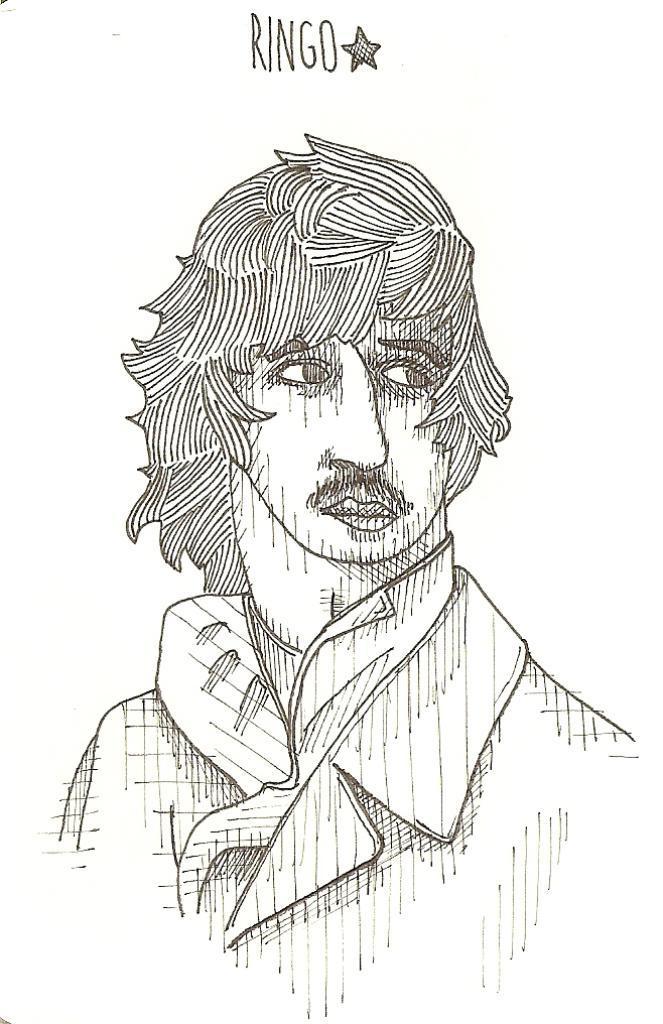Describe this image in one or two sentences. In this image I can see a sketch drawing of a person. On the top of it, I can see some text. 